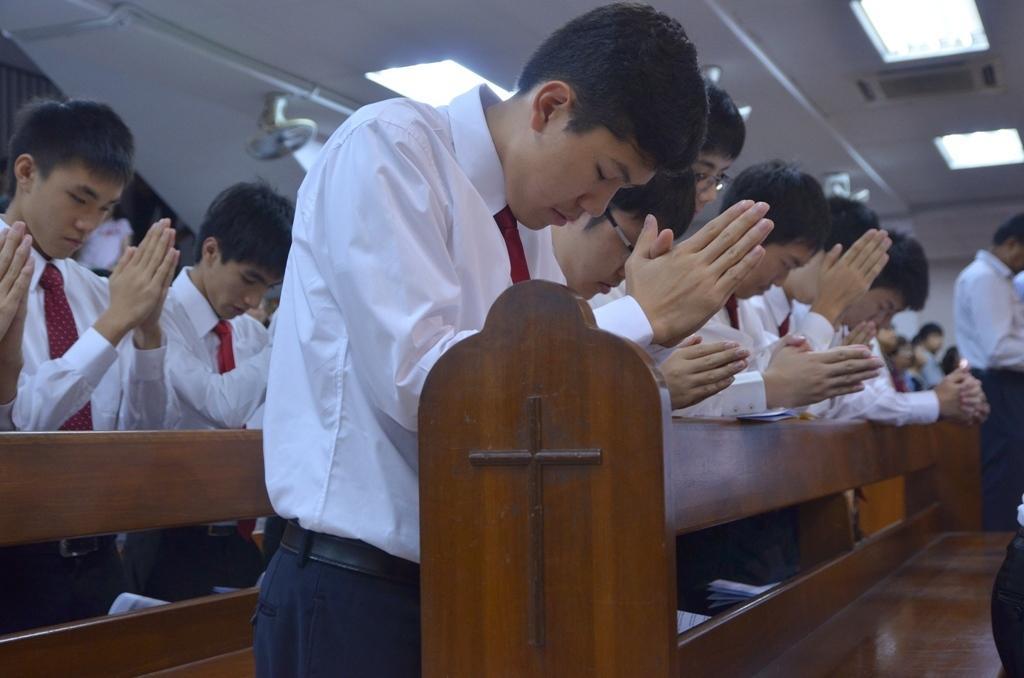Please provide a concise description of this image. In the image few people are standing and there are some benches. Top of the image there is roof and lights. 